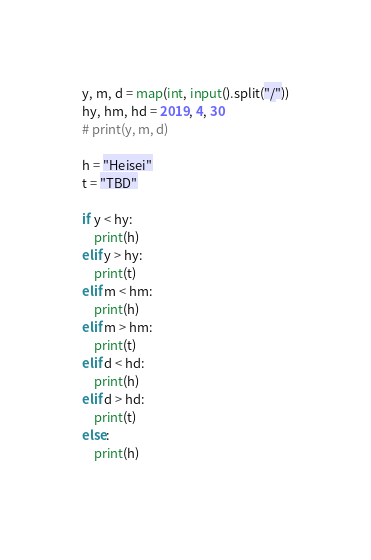Convert code to text. <code><loc_0><loc_0><loc_500><loc_500><_Python_>y, m, d = map(int, input().split("/"))
hy, hm, hd = 2019, 4, 30
# print(y, m, d)

h = "Heisei"
t = "TBD"

if y < hy:
    print(h)
elif y > hy:
    print(t)
elif m < hm:
    print(h)
elif m > hm:
    print(t)
elif d < hd:
    print(h)
elif d > hd:
    print(t)
else:
    print(h)
    
</code> 